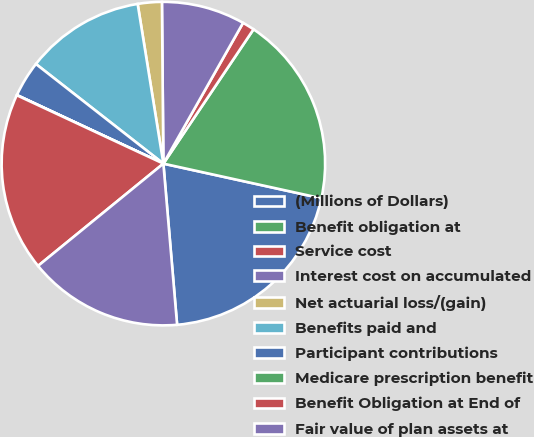Convert chart to OTSL. <chart><loc_0><loc_0><loc_500><loc_500><pie_chart><fcel>(Millions of Dollars)<fcel>Benefit obligation at<fcel>Service cost<fcel>Interest cost on accumulated<fcel>Net actuarial loss/(gain)<fcel>Benefits paid and<fcel>Participant contributions<fcel>Medicare prescription benefit<fcel>Benefit Obligation at End of<fcel>Fair value of plan assets at<nl><fcel>20.21%<fcel>19.03%<fcel>1.21%<fcel>8.34%<fcel>2.4%<fcel>11.9%<fcel>3.59%<fcel>0.02%<fcel>17.84%<fcel>15.46%<nl></chart> 